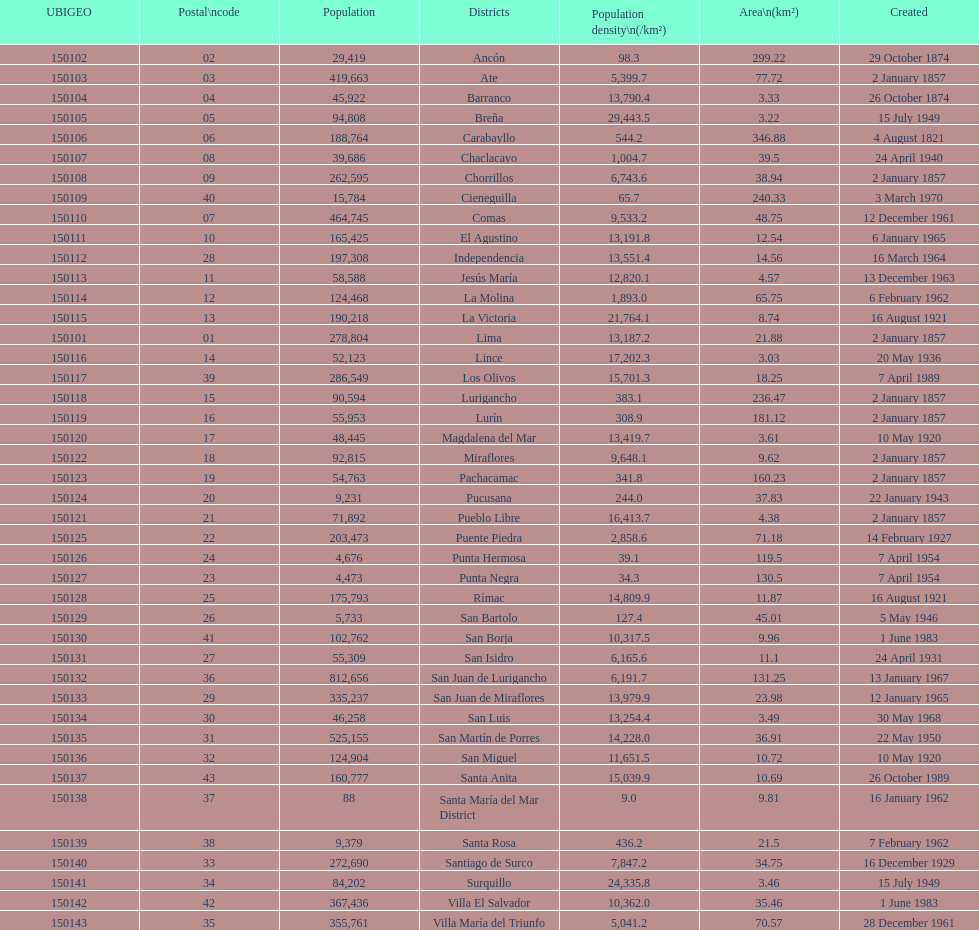What district has the least amount of population? Santa María del Mar District. 